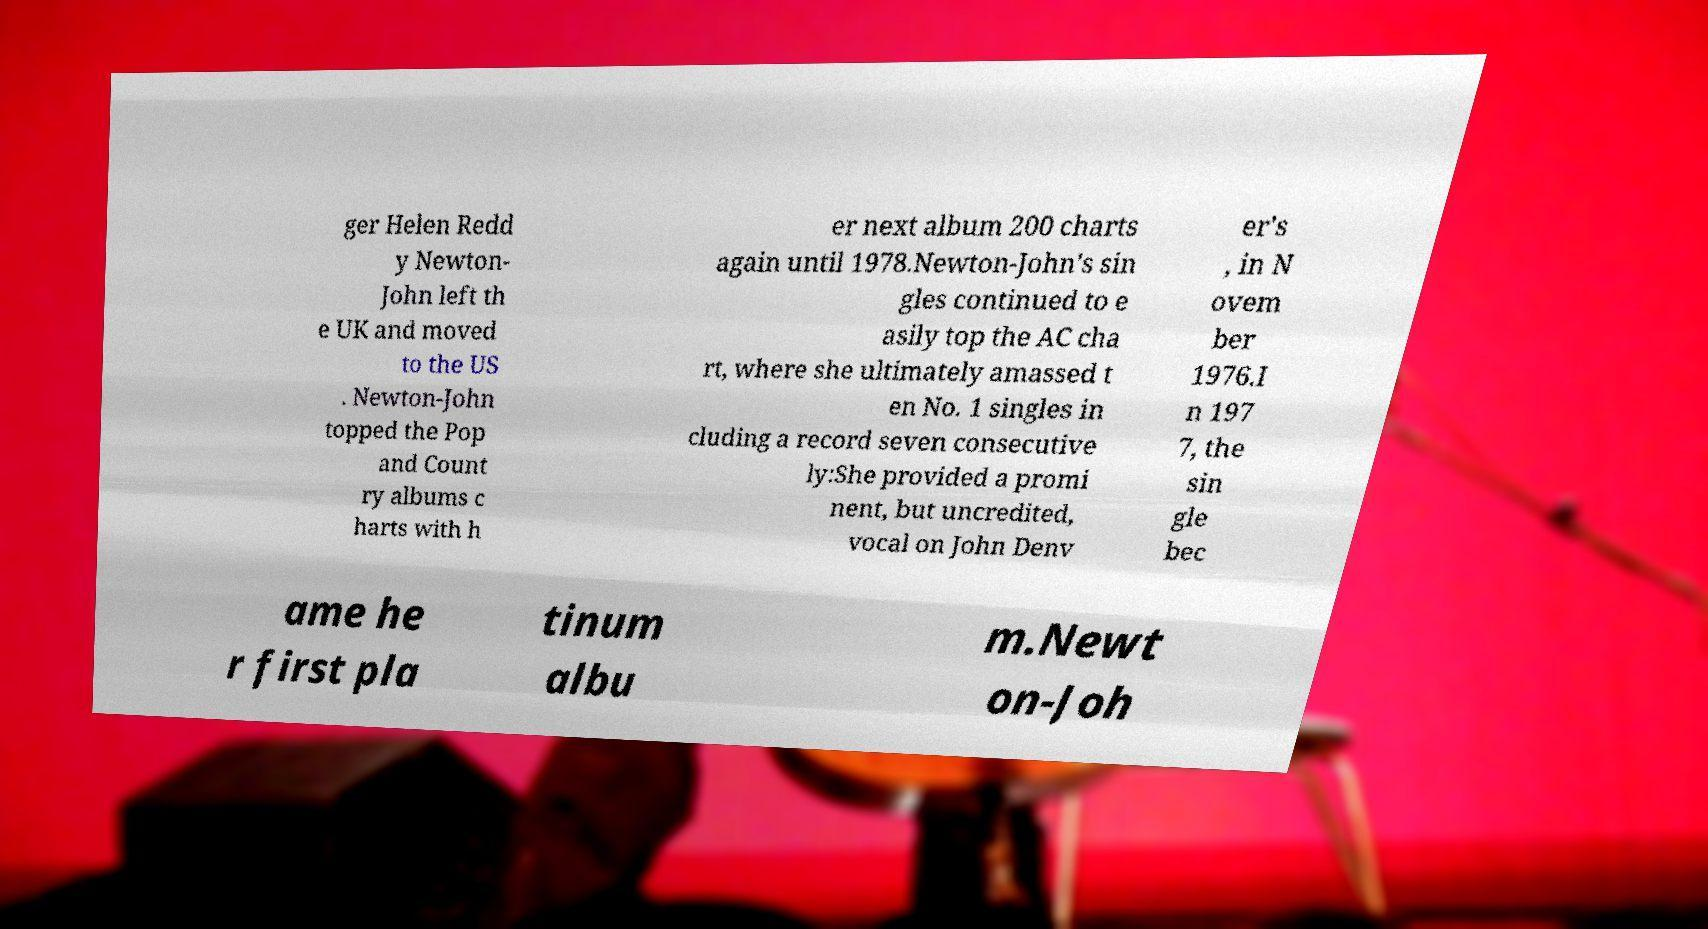Could you extract and type out the text from this image? ger Helen Redd y Newton- John left th e UK and moved to the US . Newton-John topped the Pop and Count ry albums c harts with h er next album 200 charts again until 1978.Newton-John's sin gles continued to e asily top the AC cha rt, where she ultimately amassed t en No. 1 singles in cluding a record seven consecutive ly:She provided a promi nent, but uncredited, vocal on John Denv er's , in N ovem ber 1976.I n 197 7, the sin gle bec ame he r first pla tinum albu m.Newt on-Joh 